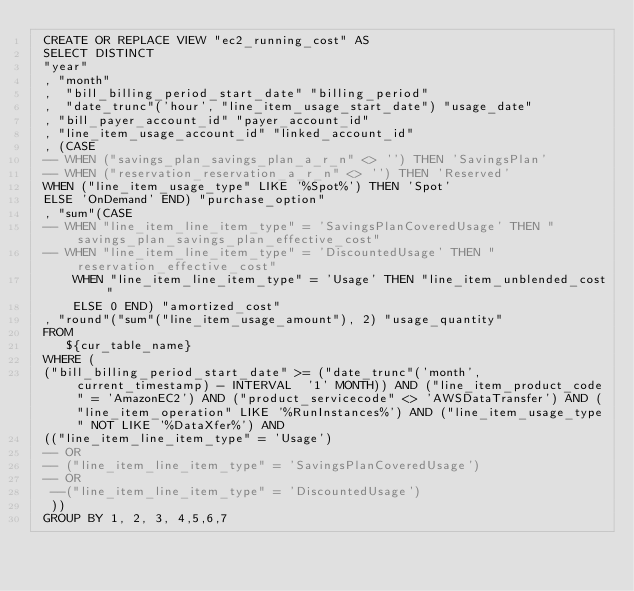Convert code to text. <code><loc_0><loc_0><loc_500><loc_500><_SQL_> CREATE OR REPLACE VIEW "ec2_running_cost" AS 
 SELECT DISTINCT
 "year"
 , "month"
 ,  "bill_billing_period_start_date" "billing_period"
 ,  "date_trunc"('hour', "line_item_usage_start_date") "usage_date"
 , "bill_payer_account_id" "payer_account_id"
 , "line_item_usage_account_id" "linked_account_id"
 , (CASE 
 -- WHEN ("savings_plan_savings_plan_a_r_n" <> '') THEN 'SavingsPlan' 
 -- WHEN ("reservation_reservation_a_r_n" <> '') THEN 'Reserved' 
 WHEN ("line_item_usage_type" LIKE '%Spot%') THEN 'Spot' 
 ELSE 'OnDemand' END) "purchase_option"
 , "sum"(CASE
 -- WHEN "line_item_line_item_type" = 'SavingsPlanCoveredUsage' THEN "savings_plan_savings_plan_effective_cost"
 -- WHEN "line_item_line_item_type" = 'DiscountedUsage' THEN "reservation_effective_cost"
     WHEN "line_item_line_item_type" = 'Usage' THEN "line_item_unblended_cost"
     ELSE 0 END) "amortized_cost"
 , "round"("sum"("line_item_usage_amount"), 2) "usage_quantity"
 FROM
    ${cur_table_name}
 WHERE (
 ("bill_billing_period_start_date" >= ("date_trunc"('month', current_timestamp) - INTERVAL  '1' MONTH)) AND ("line_item_product_code" = 'AmazonEC2') AND ("product_servicecode" <> 'AWSDataTransfer') AND ("line_item_operation" LIKE '%RunInstances%') AND ("line_item_usage_type" NOT LIKE '%DataXfer%') AND 
 (("line_item_line_item_type" = 'Usage') 
 -- OR
 -- ("line_item_line_item_type" = 'SavingsPlanCoveredUsage') 
 -- OR 
  --("line_item_line_item_type" = 'DiscountedUsage')
  ))
 GROUP BY 1, 2, 3, 4,5,6,7
</code> 